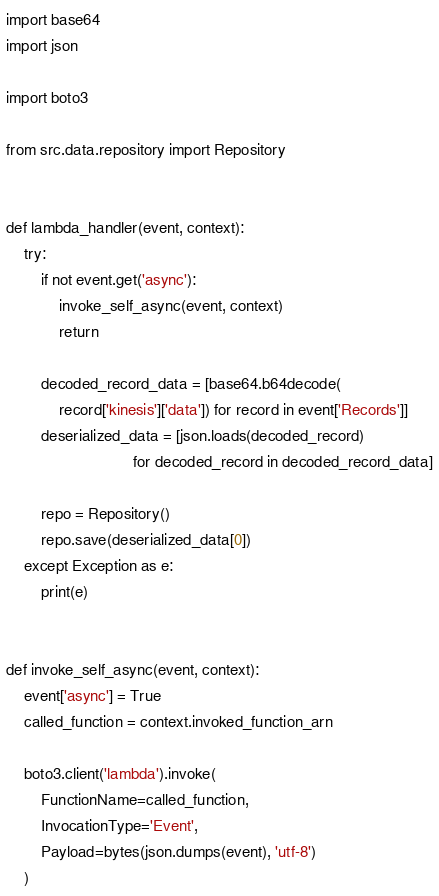Convert code to text. <code><loc_0><loc_0><loc_500><loc_500><_Python_>import base64
import json

import boto3

from src.data.repository import Repository


def lambda_handler(event, context):
    try:
        if not event.get('async'):
            invoke_self_async(event, context)
            return

        decoded_record_data = [base64.b64decode(
            record['kinesis']['data']) for record in event['Records']]
        deserialized_data = [json.loads(decoded_record)
                             for decoded_record in decoded_record_data]

        repo = Repository()
        repo.save(deserialized_data[0])
    except Exception as e:
        print(e)


def invoke_self_async(event, context):
    event['async'] = True
    called_function = context.invoked_function_arn

    boto3.client('lambda').invoke(
        FunctionName=called_function,
        InvocationType='Event',
        Payload=bytes(json.dumps(event), 'utf-8')
    )
</code> 